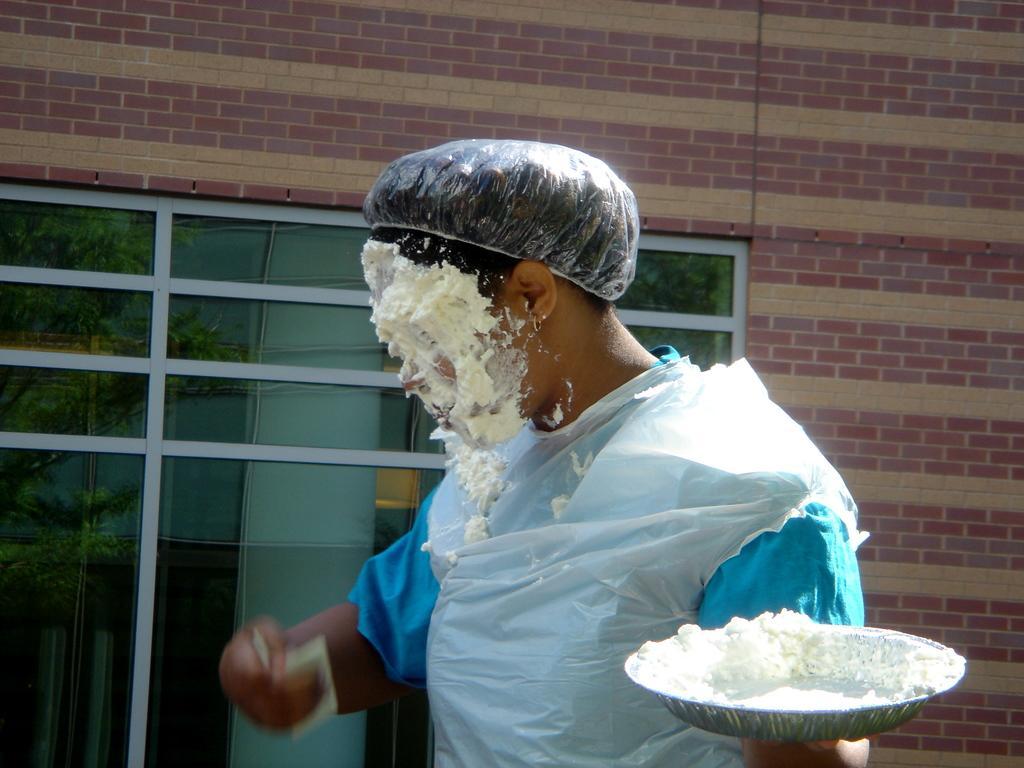How would you summarize this image in a sentence or two? In front of the image there is a person holding the bowl and some object in his hands. Behind him there is a wall with glass windows through which we can see trees. 